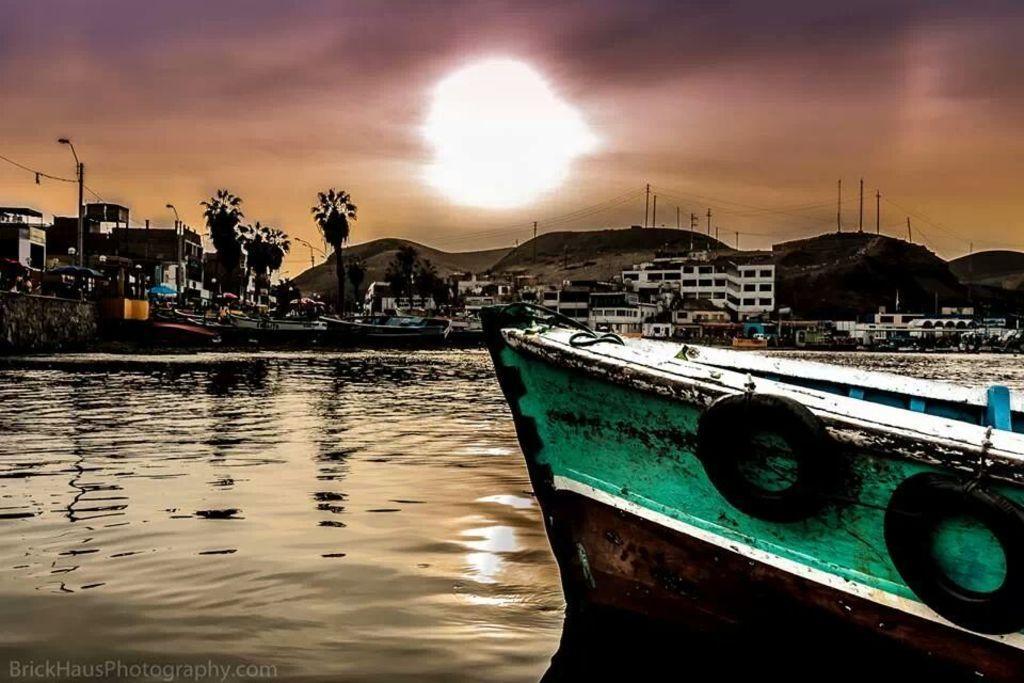Could you give a brief overview of what you see in this image? In this picture I can see few boats on the water. I can see buildings, trees, few poles and I can see text at the bottom left corner of the picture. 